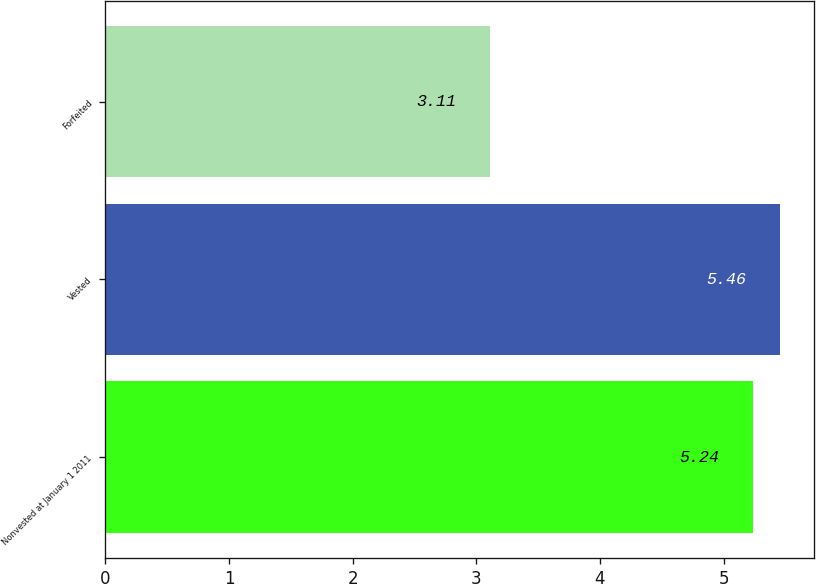Convert chart to OTSL. <chart><loc_0><loc_0><loc_500><loc_500><bar_chart><fcel>Nonvested at January 1 2011<fcel>Vested<fcel>Forfeited<nl><fcel>5.24<fcel>5.46<fcel>3.11<nl></chart> 